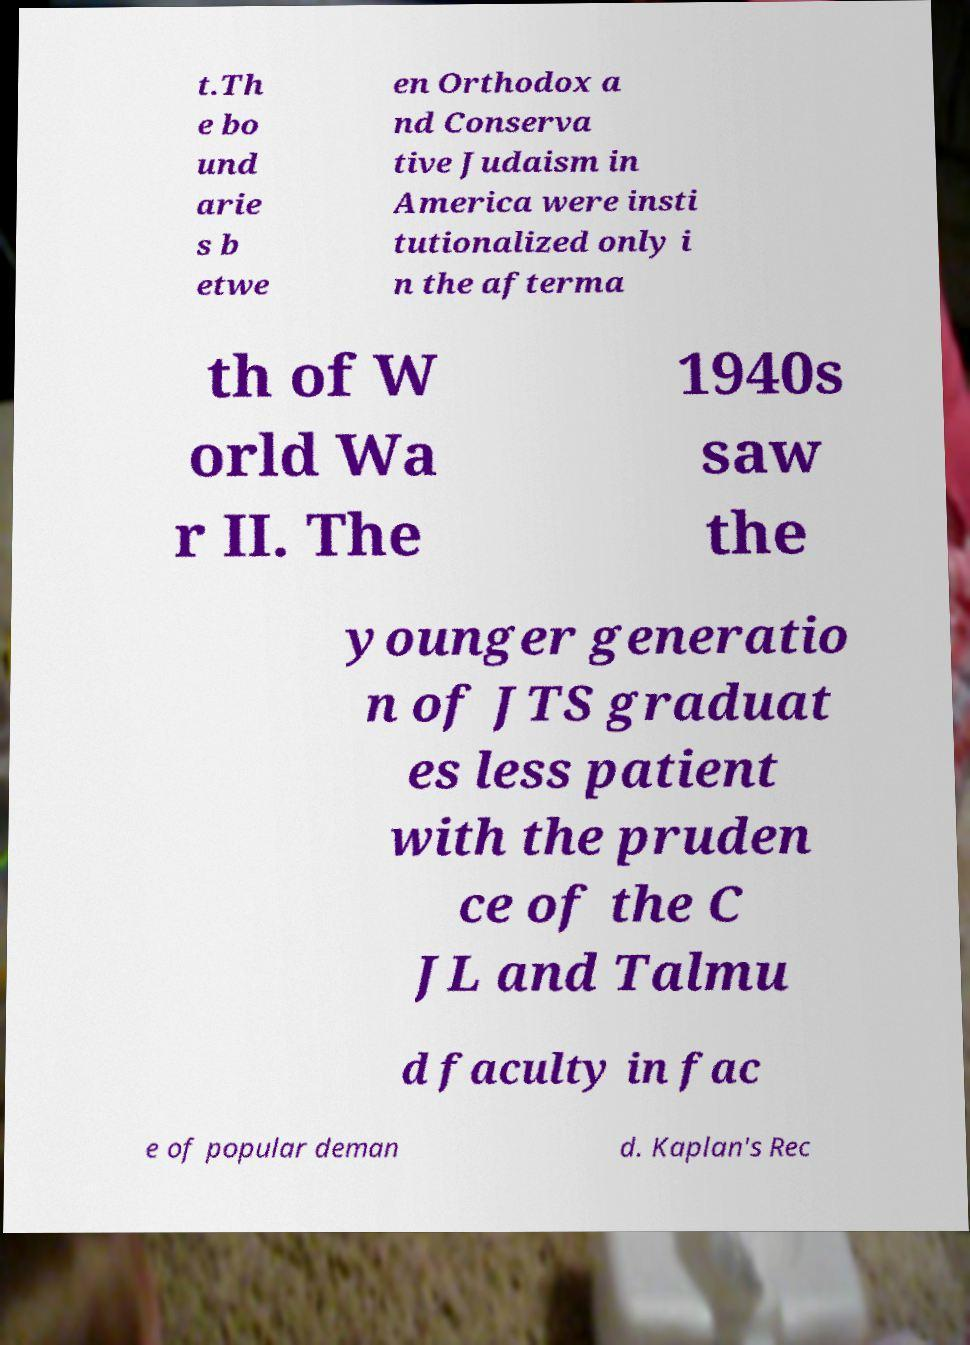Please identify and transcribe the text found in this image. t.Th e bo und arie s b etwe en Orthodox a nd Conserva tive Judaism in America were insti tutionalized only i n the afterma th of W orld Wa r II. The 1940s saw the younger generatio n of JTS graduat es less patient with the pruden ce of the C JL and Talmu d faculty in fac e of popular deman d. Kaplan's Rec 